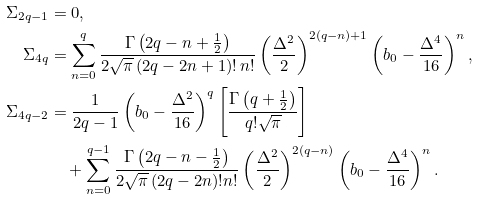Convert formula to latex. <formula><loc_0><loc_0><loc_500><loc_500>\Sigma _ { 2 q - 1 } & = 0 , \\ \Sigma _ { 4 q } & = \sum _ { n = 0 } ^ { q } \frac { \Gamma \left ( 2 q - n + \frac { 1 } { 2 } \right ) } { 2 \sqrt { \pi } \left ( 2 q - 2 n + 1 \right ) ! \, n ! } \left ( \frac { \Delta ^ { 2 } } { 2 } \right ) ^ { 2 ( q - n ) + 1 } \left ( b _ { 0 } - \frac { \Delta ^ { 4 } } { 1 6 } \right ) ^ { n } , \\ \Sigma _ { 4 q - 2 } & = \frac { 1 } { 2 q - 1 } \left ( b _ { 0 } - \frac { \Delta ^ { 2 } } { 1 6 } \right ) ^ { q } \left [ \frac { \Gamma \left ( q + \frac { 1 } { 2 } \right ) } { q ! \sqrt { \pi } } \right ] \\ & \quad + \sum _ { n = 0 } ^ { q - 1 } \frac { \Gamma \left ( 2 q - n - \frac { 1 } { 2 } \right ) } { 2 \sqrt { \pi } \left ( 2 q - 2 n \right ) ! n ! } \left ( \frac { \Delta ^ { 2 } } { 2 } \right ) ^ { 2 ( q - n ) } \left ( b _ { 0 } - \frac { \Delta ^ { 4 } } { 1 6 } \right ) ^ { n } .</formula> 